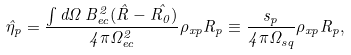<formula> <loc_0><loc_0><loc_500><loc_500>\hat { \eta } _ { p } = \frac { \int d \Omega \, B _ { e c } ^ { 2 } ( \hat { R } - \hat { R _ { 0 } } ) } { 4 \pi \Omega _ { e c } ^ { 2 } } \rho _ { x p } R _ { p } \equiv \frac { s _ { p } } { 4 \pi \Omega _ { s q } } \rho _ { x p } R _ { p } ,</formula> 